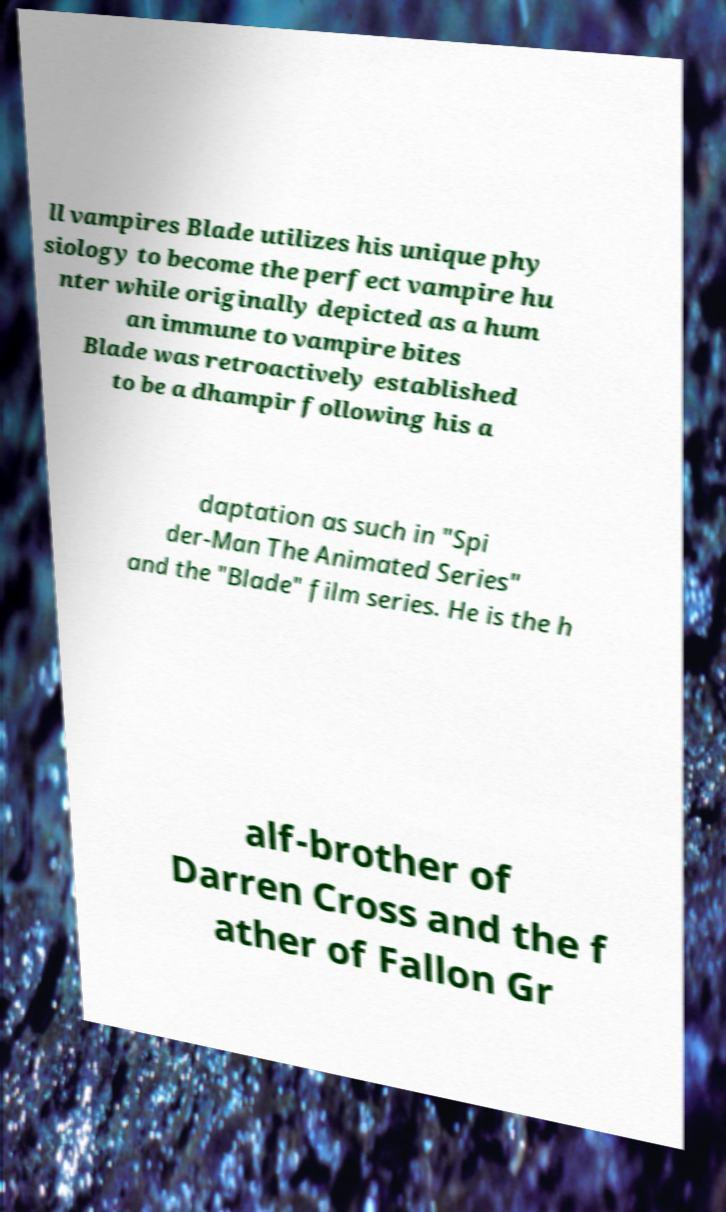Please identify and transcribe the text found in this image. ll vampires Blade utilizes his unique phy siology to become the perfect vampire hu nter while originally depicted as a hum an immune to vampire bites Blade was retroactively established to be a dhampir following his a daptation as such in "Spi der-Man The Animated Series" and the "Blade" film series. He is the h alf-brother of Darren Cross and the f ather of Fallon Gr 